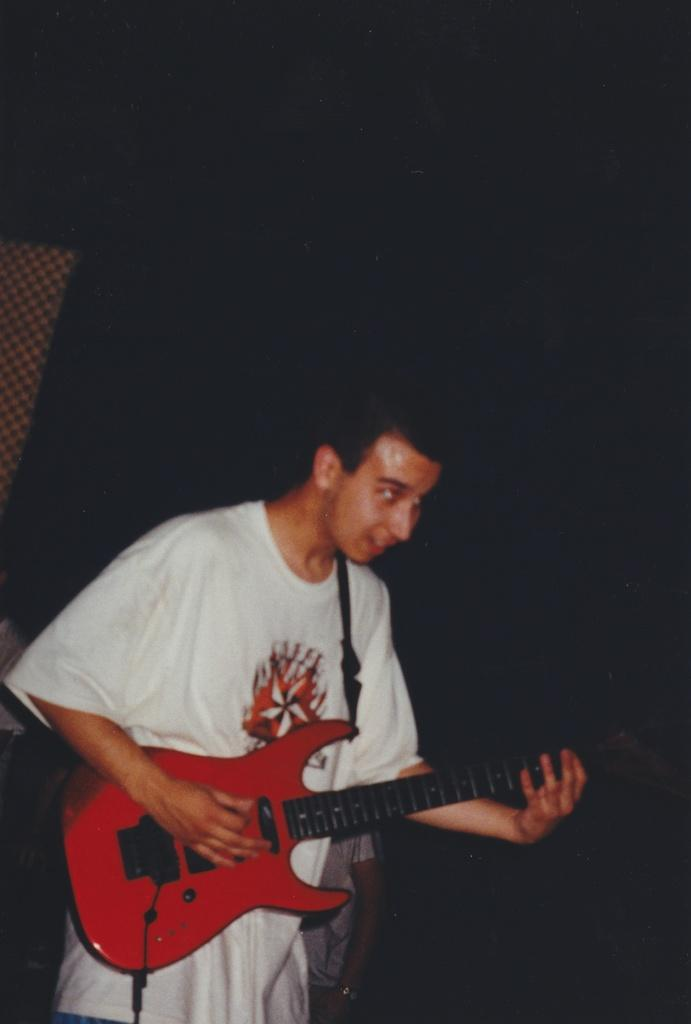What is the main subject of the image? There is a person standing in the image. What is the person doing in the image? The person is playing a guitar. Can you describe the secondary subject in the image? There is another person in the background of the image. What time of day is it in the image, and how does the mother feel about the afternoon? The time of day is not mentioned in the image, and there is no indication of a mother or her feelings about the afternoon. 